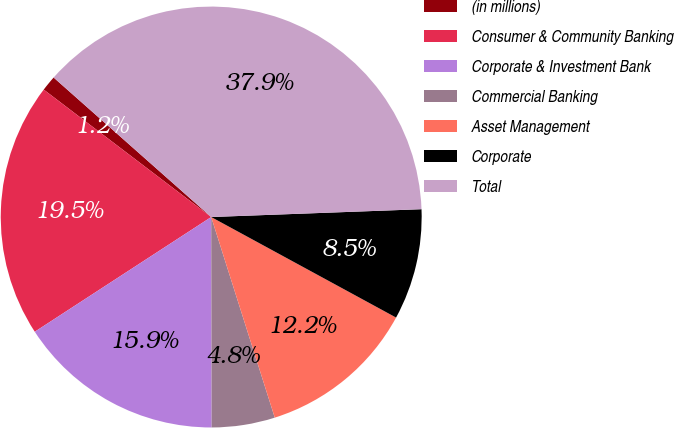Convert chart to OTSL. <chart><loc_0><loc_0><loc_500><loc_500><pie_chart><fcel>(in millions)<fcel>Consumer & Community Banking<fcel>Corporate & Investment Bank<fcel>Commercial Banking<fcel>Asset Management<fcel>Corporate<fcel>Total<nl><fcel>1.18%<fcel>19.53%<fcel>15.86%<fcel>4.85%<fcel>12.19%<fcel>8.52%<fcel>37.88%<nl></chart> 